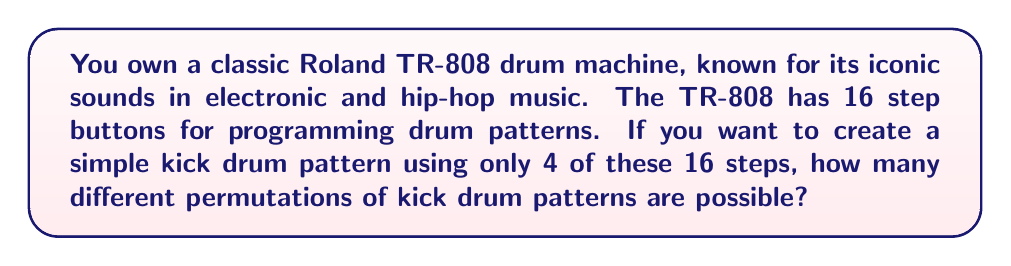Provide a solution to this math problem. To solve this problem, we need to use the concept of permutations. Here's a step-by-step explanation:

1. We have 16 total steps available on the TR-808.
2. We want to select 4 of these steps for our kick drum pattern.
3. The order of selection matters, as different arrangements of the 4 kicks will create different rhythms.
4. This scenario is a permutation without repetition, as we can't use the same step more than once.

The formula for permutations without repetition is:

$$P(n,r) = \frac{n!}{(n-r)!}$$

Where:
$n$ = total number of items to choose from
$r$ = number of items being chosen

In our case:
$n = 16$ (total steps on the TR-808)
$r = 4$ (number of kicks we're programming)

Let's plug these values into our formula:

$$P(16,4) = \frac{16!}{(16-4)!} = \frac{16!}{12!}$$

Expanding this:

$$\frac{16 \times 15 \times 14 \times 13 \times 12!}{12!}$$

The $12!$ cancels out in the numerator and denominator:

$$16 \times 15 \times 14 \times 13 = 43,680$$

Therefore, there are 43,680 different permutations of kick drum patterns possible using 4 out of 16 steps on the TR-808.
Answer: 43,680 permutations 